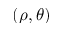Convert formula to latex. <formula><loc_0><loc_0><loc_500><loc_500>( \rho , \theta )</formula> 